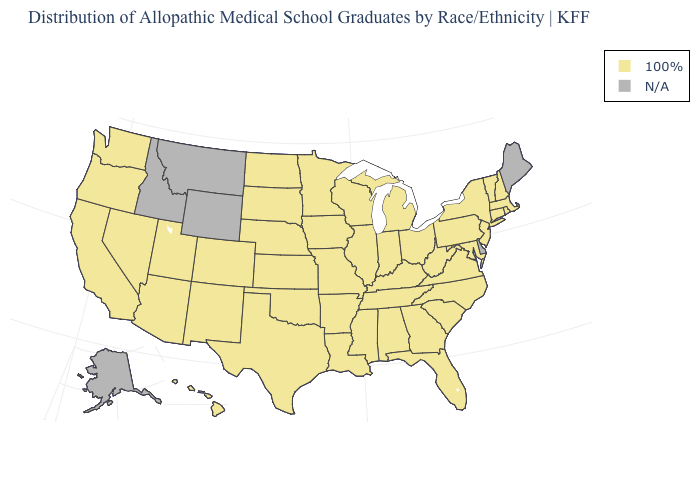What is the value of South Dakota?
Be succinct. 100%. Which states hav the highest value in the MidWest?
Write a very short answer. Illinois, Indiana, Iowa, Kansas, Michigan, Minnesota, Missouri, Nebraska, North Dakota, Ohio, South Dakota, Wisconsin. Among the states that border Virginia , which have the highest value?
Quick response, please. Kentucky, Maryland, North Carolina, Tennessee, West Virginia. Name the states that have a value in the range 100%?
Answer briefly. Alabama, Arizona, Arkansas, California, Colorado, Connecticut, Florida, Georgia, Hawaii, Illinois, Indiana, Iowa, Kansas, Kentucky, Louisiana, Maryland, Massachusetts, Michigan, Minnesota, Mississippi, Missouri, Nebraska, Nevada, New Hampshire, New Jersey, New Mexico, New York, North Carolina, North Dakota, Ohio, Oklahoma, Oregon, Pennsylvania, Rhode Island, South Carolina, South Dakota, Tennessee, Texas, Utah, Vermont, Virginia, Washington, West Virginia, Wisconsin. What is the lowest value in the West?
Answer briefly. 100%. What is the highest value in states that border Illinois?
Keep it brief. 100%. Name the states that have a value in the range N/A?
Quick response, please. Alaska, Delaware, Idaho, Maine, Montana, Wyoming. What is the value of California?
Short answer required. 100%. What is the value of Wisconsin?
Be succinct. 100%. What is the lowest value in states that border West Virginia?
Keep it brief. 100%. What is the lowest value in the USA?
Answer briefly. 100%. Which states have the lowest value in the MidWest?
Short answer required. Illinois, Indiana, Iowa, Kansas, Michigan, Minnesota, Missouri, Nebraska, North Dakota, Ohio, South Dakota, Wisconsin. What is the highest value in the MidWest ?
Short answer required. 100%. What is the value of Ohio?
Give a very brief answer. 100%. 